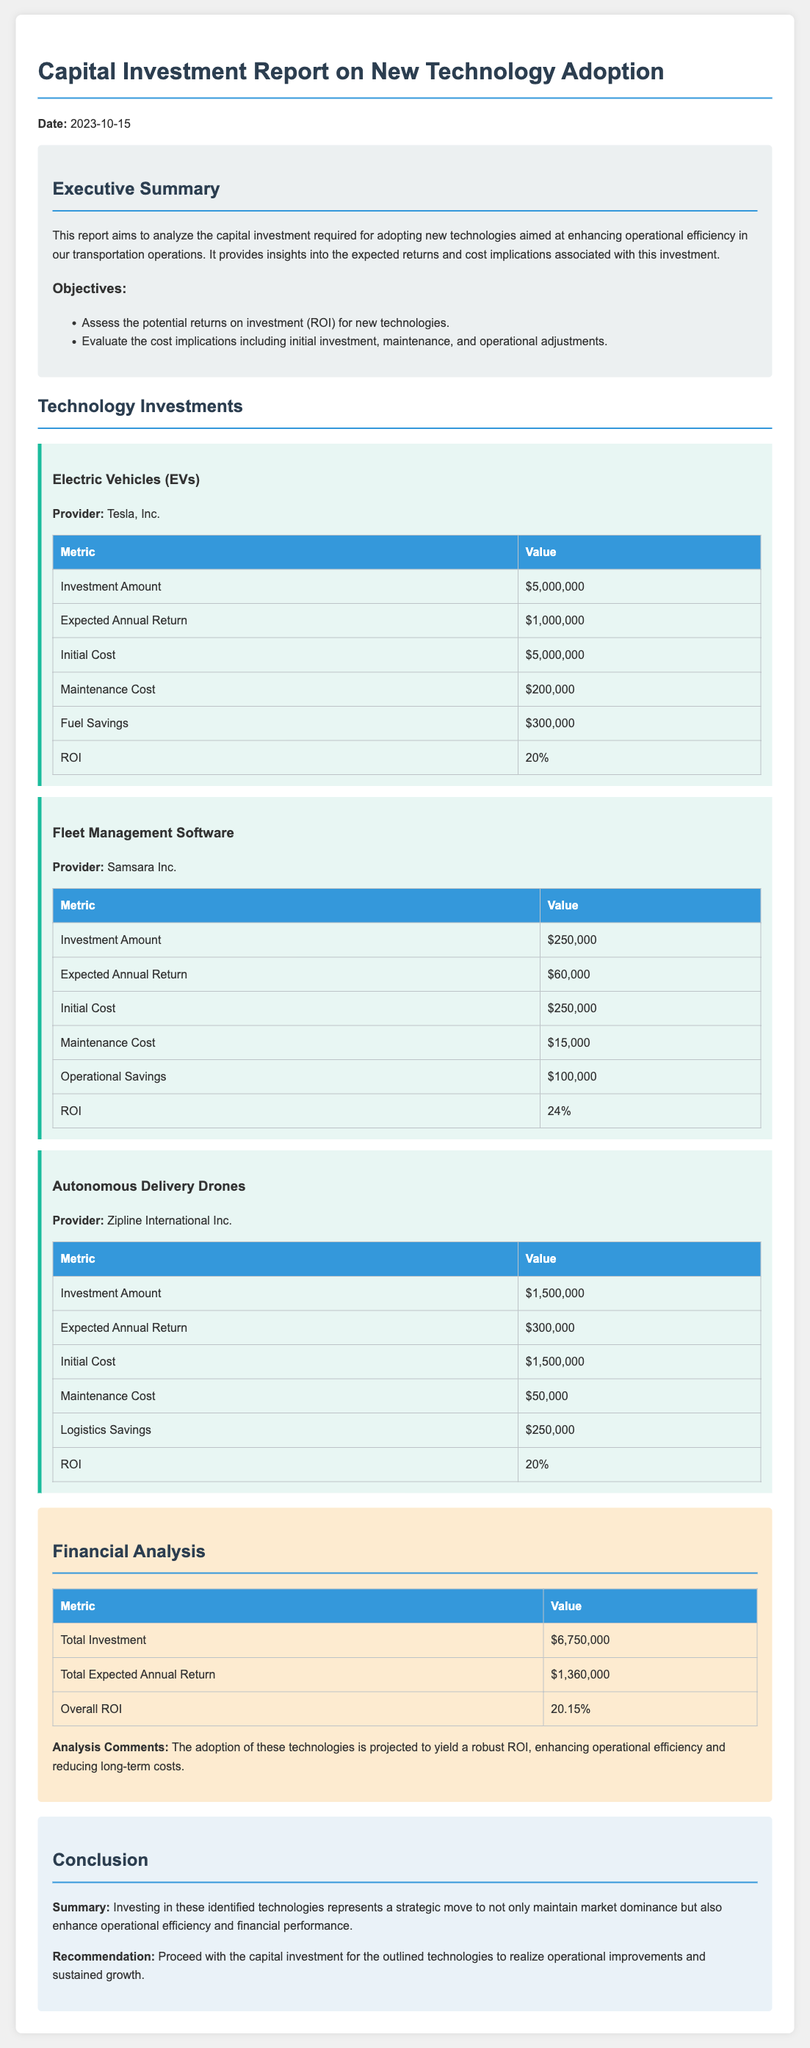what is the date of the report? The date of the report is specifically mentioned in the document as 2023-10-15.
Answer: 2023-10-15 what is the total expected annual return from all technologies? The total expected annual return is calculated from the expected returns for each technology, which adds up to $1,360,000.
Answer: $1,360,000 what is the investment amount for Electric Vehicles? The investment amount for Electric Vehicles is specified in the report and is $5,000,000.
Answer: $5,000,000 what is the overall ROI stated in the report? The overall ROI is provided as a single value in the financial analysis section of the document, which is 20.15%.
Answer: 20.15% how much is the maintenance cost for Fleet Management Software? The maintenance cost for Fleet Management Software is detailed in a table within the document as $15,000.
Answer: $15,000 which provider is associated with Autonomous Delivery Drones? The document states that Zipline International Inc. is the provider for Autonomous Delivery Drones.
Answer: Zipline International Inc what is the operational savings associated with Fleet Management Software? The operational savings for Fleet Management Software is given in the report as $100,000.
Answer: $100,000 what is the recommendation provided in the conclusion? The recommendation at the end of the report suggests proceeding with the investment in outlined technologies for operational improvements.
Answer: Proceed with the capital investment 